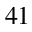Convert formula to latex. <formula><loc_0><loc_0><loc_500><loc_500>_ { 4 1 }</formula> 